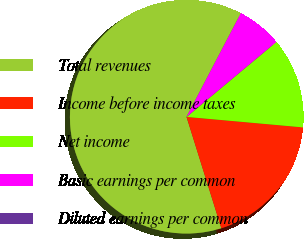Convert chart. <chart><loc_0><loc_0><loc_500><loc_500><pie_chart><fcel>Total revenues<fcel>Income before income taxes<fcel>Net income<fcel>Basic earnings per common<fcel>Diluted earnings per common<nl><fcel>62.5%<fcel>18.75%<fcel>12.5%<fcel>6.25%<fcel>0.0%<nl></chart> 